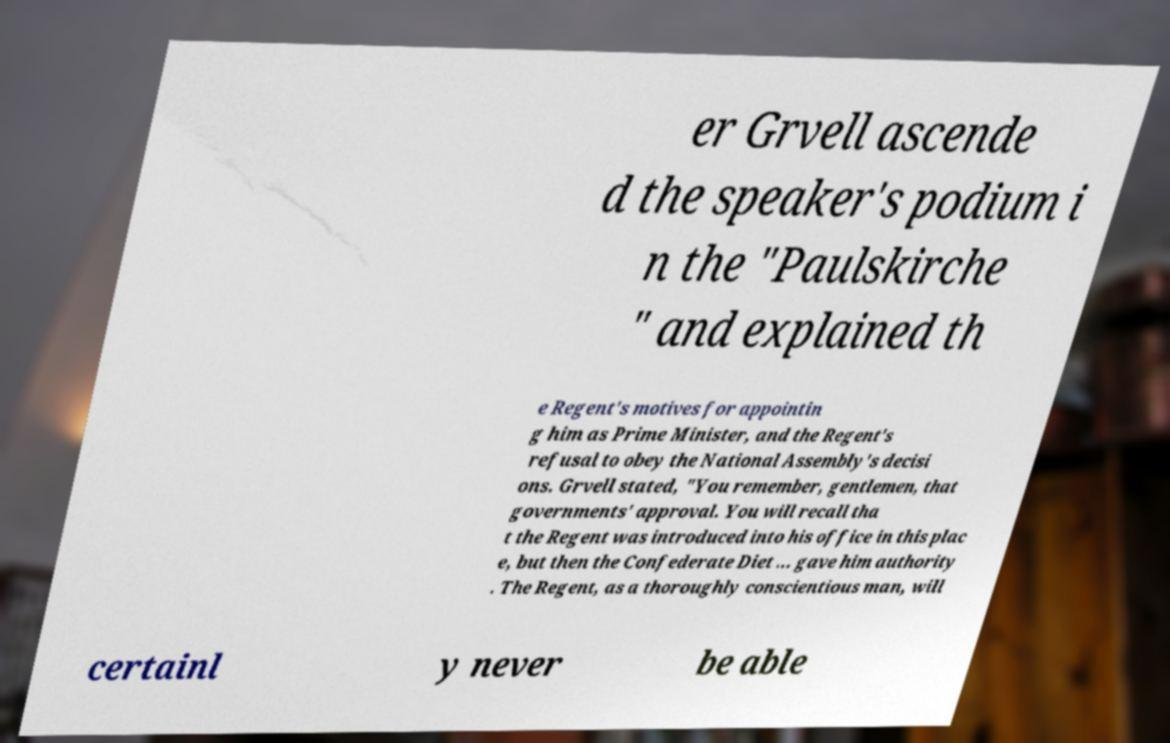Please read and relay the text visible in this image. What does it say? er Grvell ascende d the speaker's podium i n the "Paulskirche " and explained th e Regent's motives for appointin g him as Prime Minister, and the Regent's refusal to obey the National Assembly's decisi ons. Grvell stated, "You remember, gentlemen, that governments' approval. You will recall tha t the Regent was introduced into his office in this plac e, but then the Confederate Diet ... gave him authority . The Regent, as a thoroughly conscientious man, will certainl y never be able 